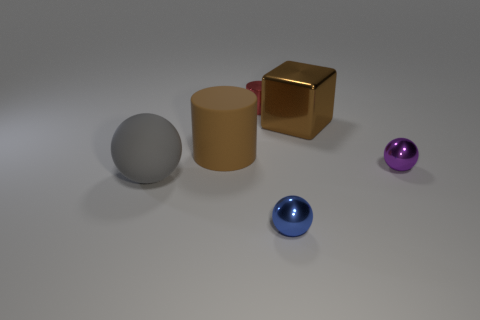The ball that is both on the right side of the matte cylinder and in front of the small purple metallic thing is made of what material?
Make the answer very short. Metal. There is a purple thing that is made of the same material as the small blue object; what is its shape?
Provide a succinct answer. Sphere. There is a big rubber object that is in front of the brown cylinder; how many big gray rubber objects are behind it?
Your response must be concise. 0. What number of balls are both left of the large metal object and to the right of the metallic cylinder?
Your answer should be very brief. 1. What number of other things are there of the same material as the gray thing
Provide a succinct answer. 1. There is a big thing that is behind the big brown object left of the tiny blue ball; what is its color?
Your response must be concise. Brown. There is a big object that is to the right of the blue thing; is its color the same as the big cylinder?
Make the answer very short. Yes. Is the size of the red cylinder the same as the gray sphere?
Your answer should be very brief. No. There is a brown metal object that is the same size as the brown matte thing; what is its shape?
Ensure brevity in your answer.  Cube. There is a cylinder behind the metallic cube; does it have the same size as the gray matte thing?
Offer a very short reply. No. 